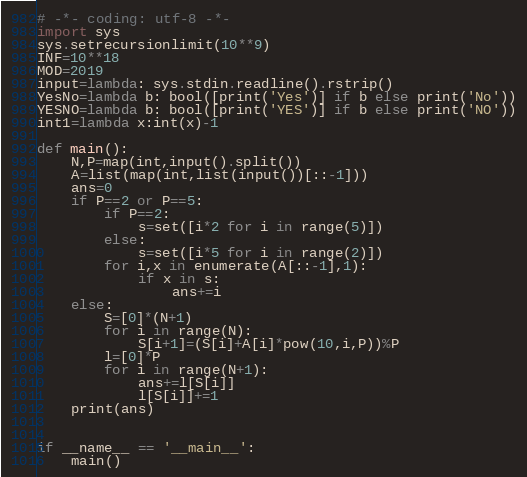Convert code to text. <code><loc_0><loc_0><loc_500><loc_500><_Python_># -*- coding: utf-8 -*-
import sys
sys.setrecursionlimit(10**9)
INF=10**18
MOD=2019
input=lambda: sys.stdin.readline().rstrip()
YesNo=lambda b: bool([print('Yes')] if b else print('No'))
YESNO=lambda b: bool([print('YES')] if b else print('NO'))
int1=lambda x:int(x)-1

def main():
    N,P=map(int,input().split())
    A=list(map(int,list(input())[::-1]))
    ans=0
    if P==2 or P==5:
        if P==2:
            s=set([i*2 for i in range(5)])
        else:
            s=set([i*5 for i in range(2)])
        for i,x in enumerate(A[::-1],1):
            if x in s:
                ans+=i
    else:
        S=[0]*(N+1)
        for i in range(N):
            S[i+1]=(S[i]+A[i]*pow(10,i,P))%P
        l=[0]*P
        for i in range(N+1):
            ans+=l[S[i]]
            l[S[i]]+=1
    print(ans)


if __name__ == '__main__':
    main()

</code> 